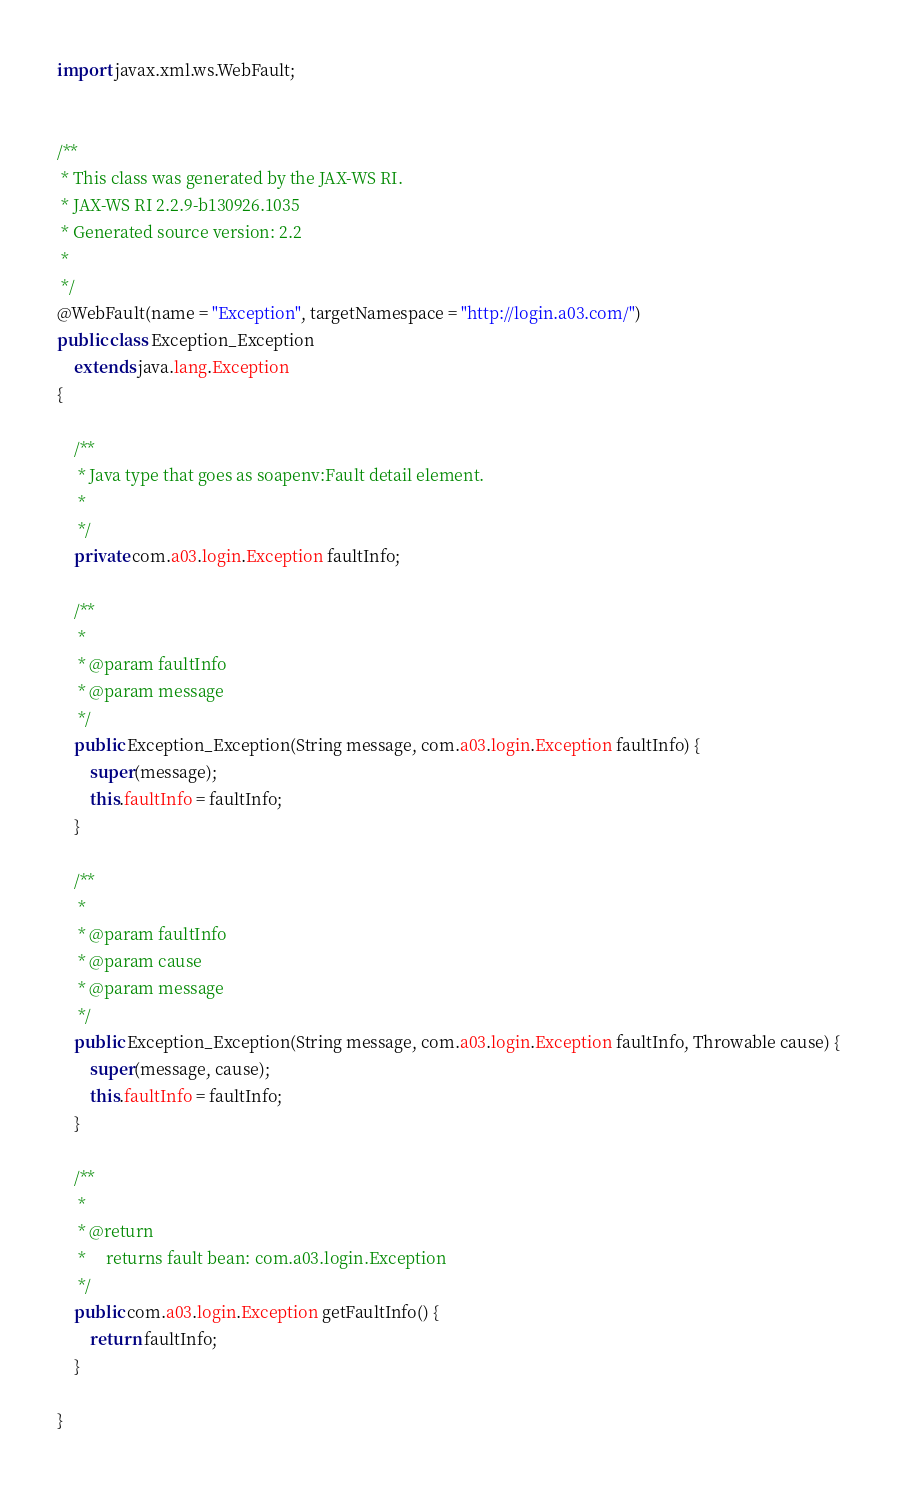Convert code to text. <code><loc_0><loc_0><loc_500><loc_500><_Java_>
import javax.xml.ws.WebFault;


/**
 * This class was generated by the JAX-WS RI.
 * JAX-WS RI 2.2.9-b130926.1035
 * Generated source version: 2.2
 * 
 */
@WebFault(name = "Exception", targetNamespace = "http://login.a03.com/")
public class Exception_Exception
    extends java.lang.Exception
{

    /**
     * Java type that goes as soapenv:Fault detail element.
     * 
     */
    private com.a03.login.Exception faultInfo;

    /**
     * 
     * @param faultInfo
     * @param message
     */
    public Exception_Exception(String message, com.a03.login.Exception faultInfo) {
        super(message);
        this.faultInfo = faultInfo;
    }

    /**
     * 
     * @param faultInfo
     * @param cause
     * @param message
     */
    public Exception_Exception(String message, com.a03.login.Exception faultInfo, Throwable cause) {
        super(message, cause);
        this.faultInfo = faultInfo;
    }

    /**
     * 
     * @return
     *     returns fault bean: com.a03.login.Exception
     */
    public com.a03.login.Exception getFaultInfo() {
        return faultInfo;
    }

}
</code> 